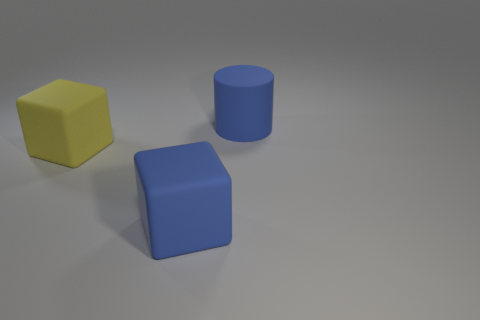Subtract all blue blocks. How many blocks are left? 1 Add 1 rubber objects. How many objects exist? 4 Subtract 1 blocks. How many blocks are left? 1 Subtract all purple cubes. Subtract all cyan balls. How many cubes are left? 2 Subtract all cyan spheres. How many blue cubes are left? 1 Subtract all large blue cylinders. Subtract all matte blocks. How many objects are left? 0 Add 1 large matte blocks. How many large matte blocks are left? 3 Add 1 yellow matte cubes. How many yellow matte cubes exist? 2 Subtract 1 blue cylinders. How many objects are left? 2 Subtract all cubes. How many objects are left? 1 